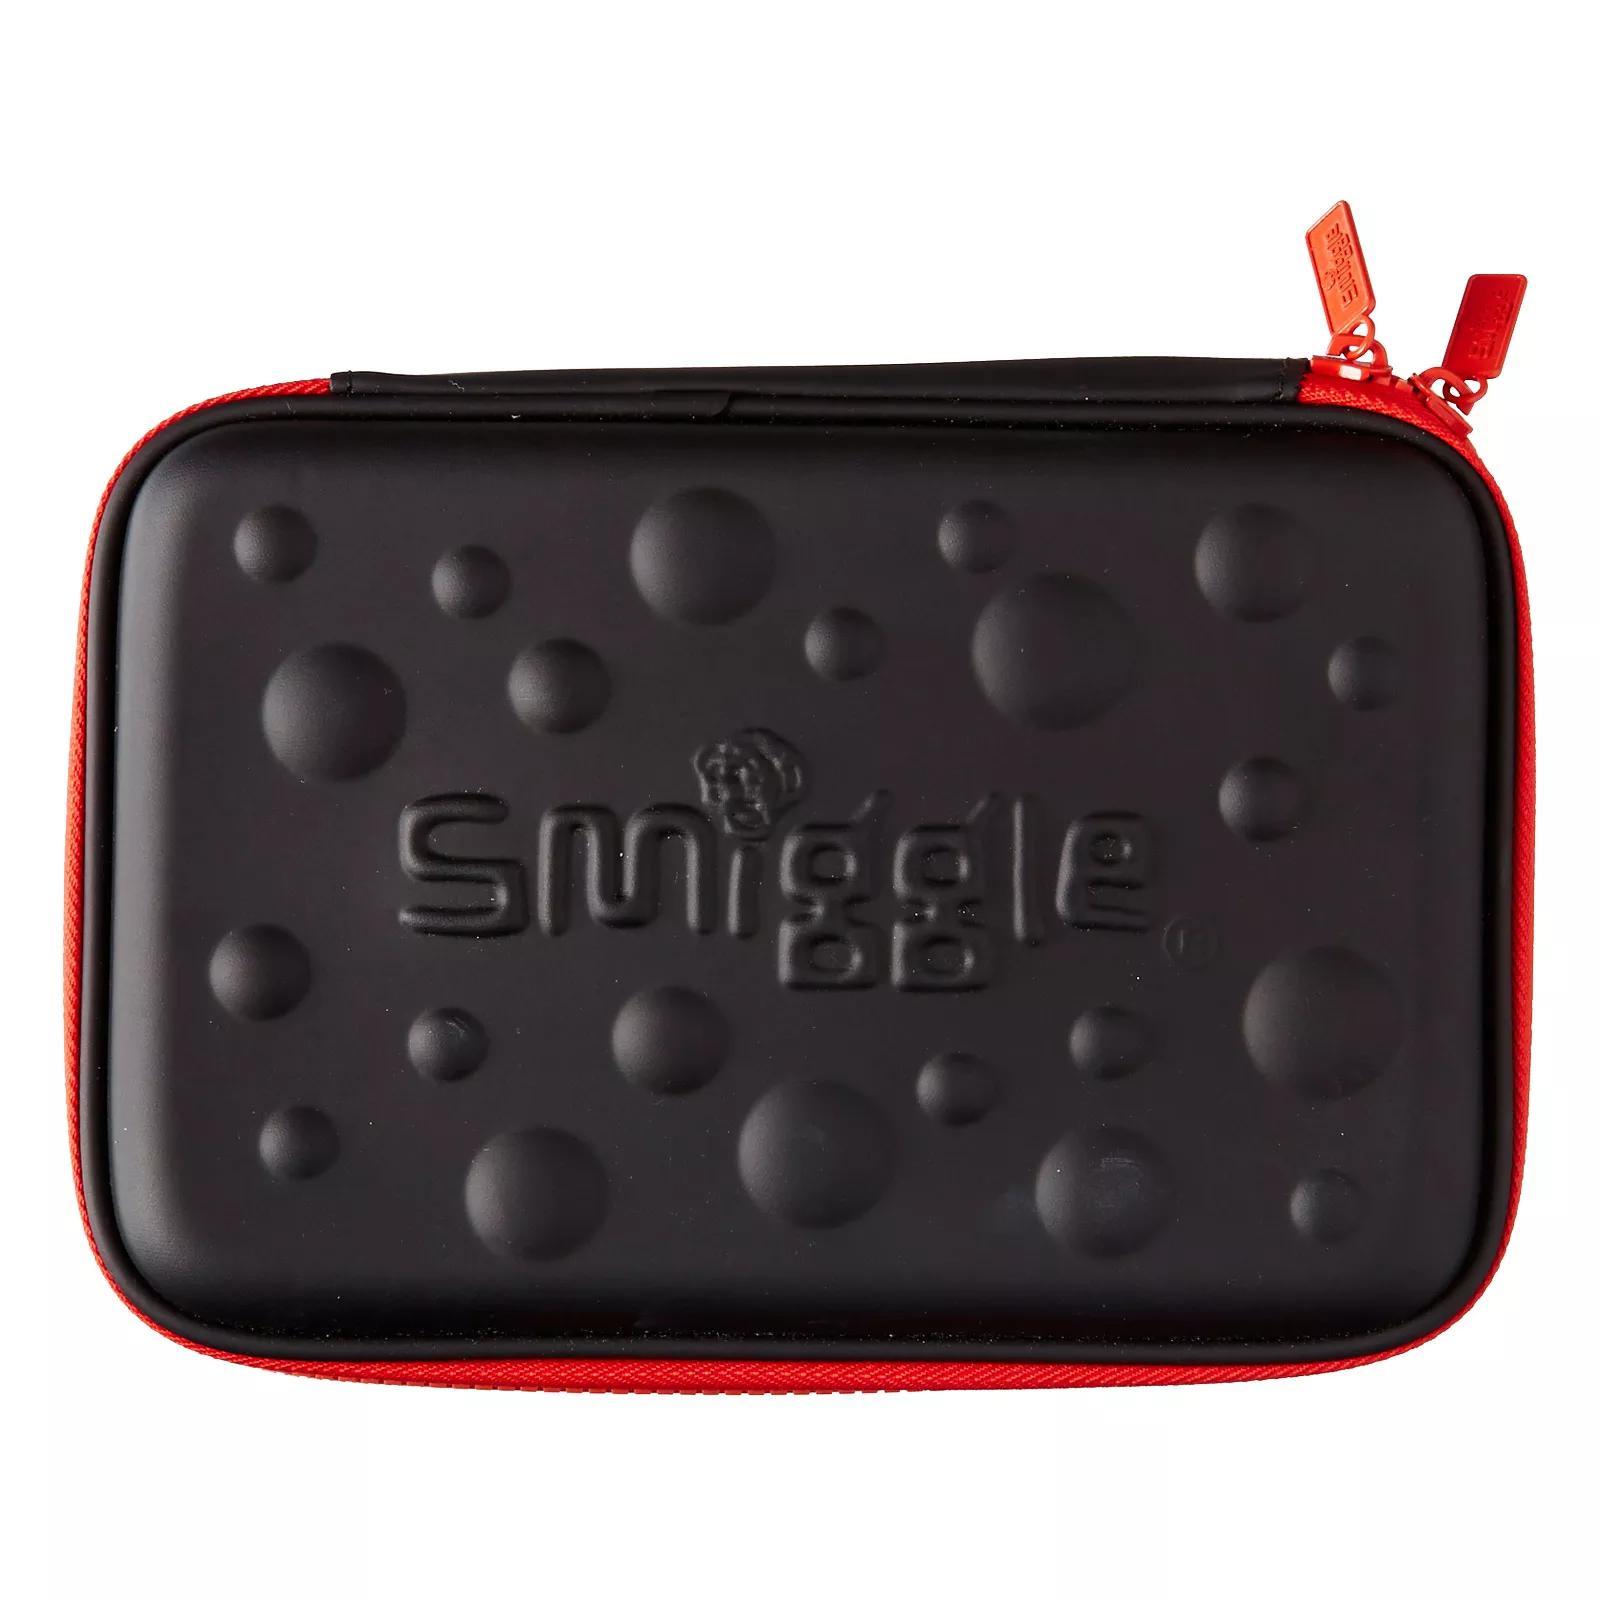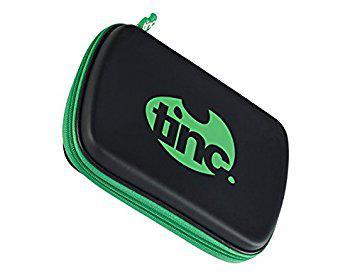The first image is the image on the left, the second image is the image on the right. Analyze the images presented: Is the assertion "there is a pencil pouch with raised bumps in varying sizes on it" valid? Answer yes or no. Yes. The first image is the image on the left, the second image is the image on the right. Analyze the images presented: Is the assertion "The black pencil case on the left is closed and has raised dots on its front, and the case on the right is also closed." valid? Answer yes or no. Yes. 